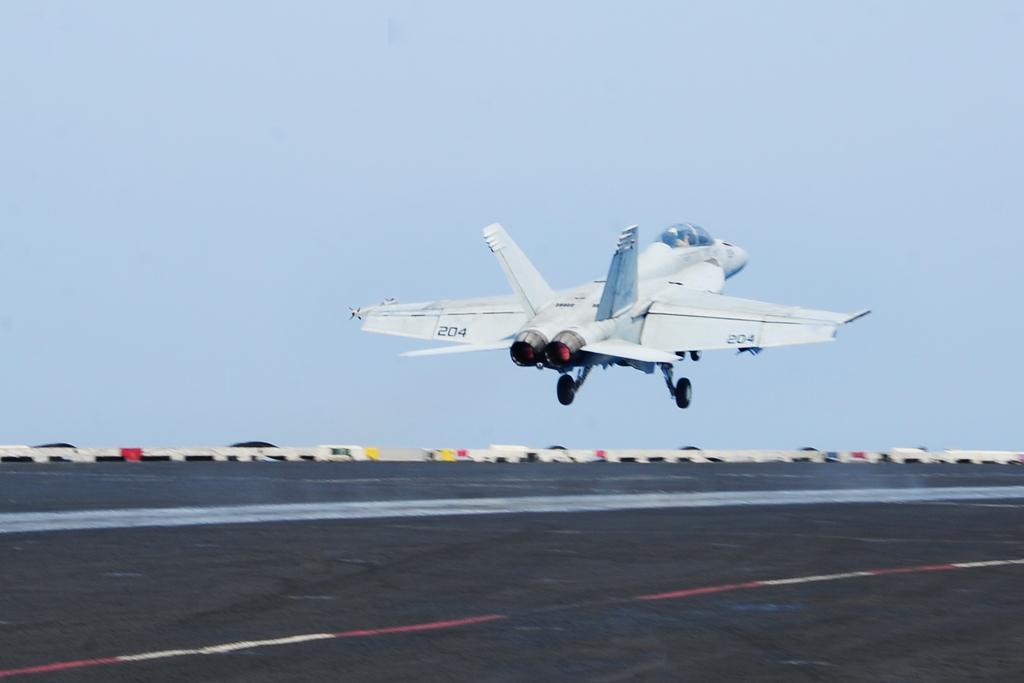In one or two sentences, can you explain what this image depicts? In this picture we can see an aircraft is flying above the runway. Behind the aircraft, there is the sky. 